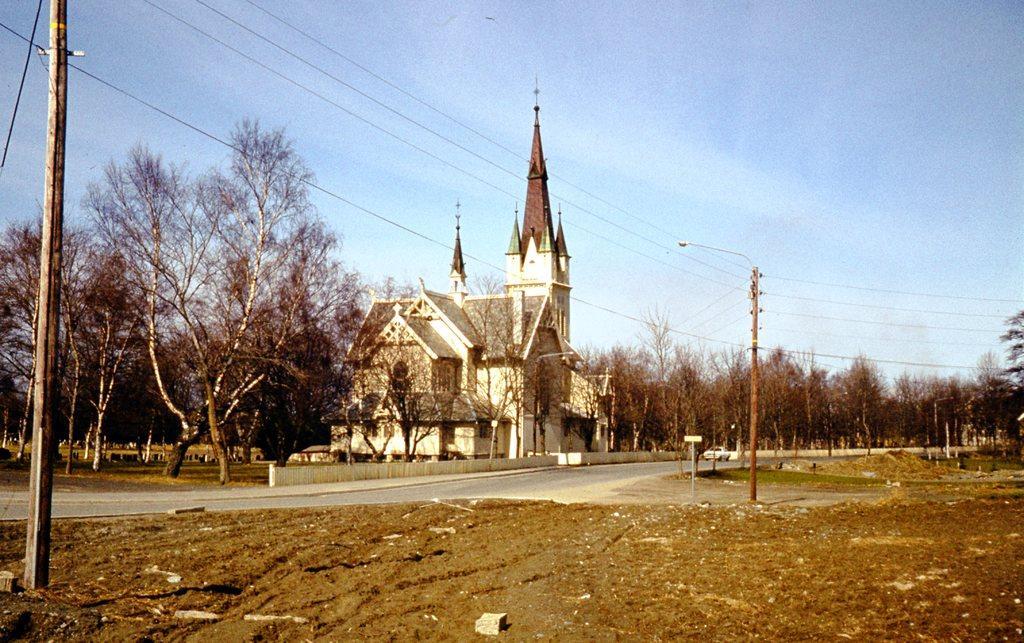Describe this image in one or two sentences. In this image we can see poles, electric wires, objects on the grass on the ground and road. In the background we can see trees, poles, building and clouds in the sky. 